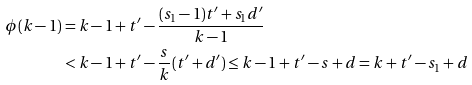Convert formula to latex. <formula><loc_0><loc_0><loc_500><loc_500>\phi ( k - 1 ) & = k - 1 + t ^ { \prime } - \frac { ( s _ { 1 } - 1 ) t ^ { \prime } + s _ { 1 } d ^ { \prime } } { k - 1 } \\ & < k - 1 + t ^ { \prime } - \frac { s } { k } ( t ^ { \prime } + d ^ { \prime } ) \leq k - 1 + t ^ { \prime } - s + d = k + t ^ { \prime } - s _ { 1 } + d</formula> 